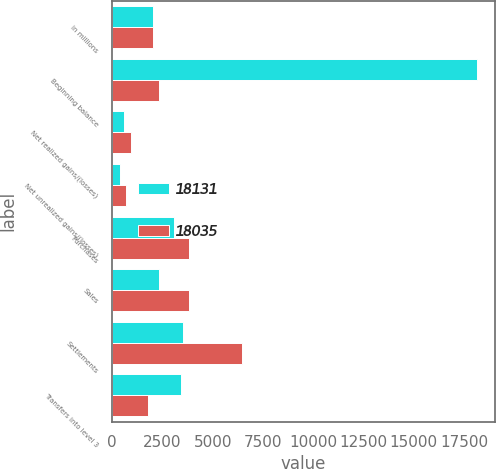Convert chart to OTSL. <chart><loc_0><loc_0><loc_500><loc_500><stacked_bar_chart><ecel><fcel>in millions<fcel>Beginning balance<fcel>Net realized gains/(losses)<fcel>Net unrealized gains/(losses)<fcel>Purchases<fcel>Sales<fcel>Settlements<fcel>Transfers into level 3<nl><fcel>18131<fcel>2016<fcel>18131<fcel>574<fcel>397<fcel>3072<fcel>2326<fcel>3503<fcel>3405<nl><fcel>18035<fcel>2015<fcel>2326<fcel>957<fcel>701<fcel>3840<fcel>3842<fcel>6472<fcel>1798<nl></chart> 